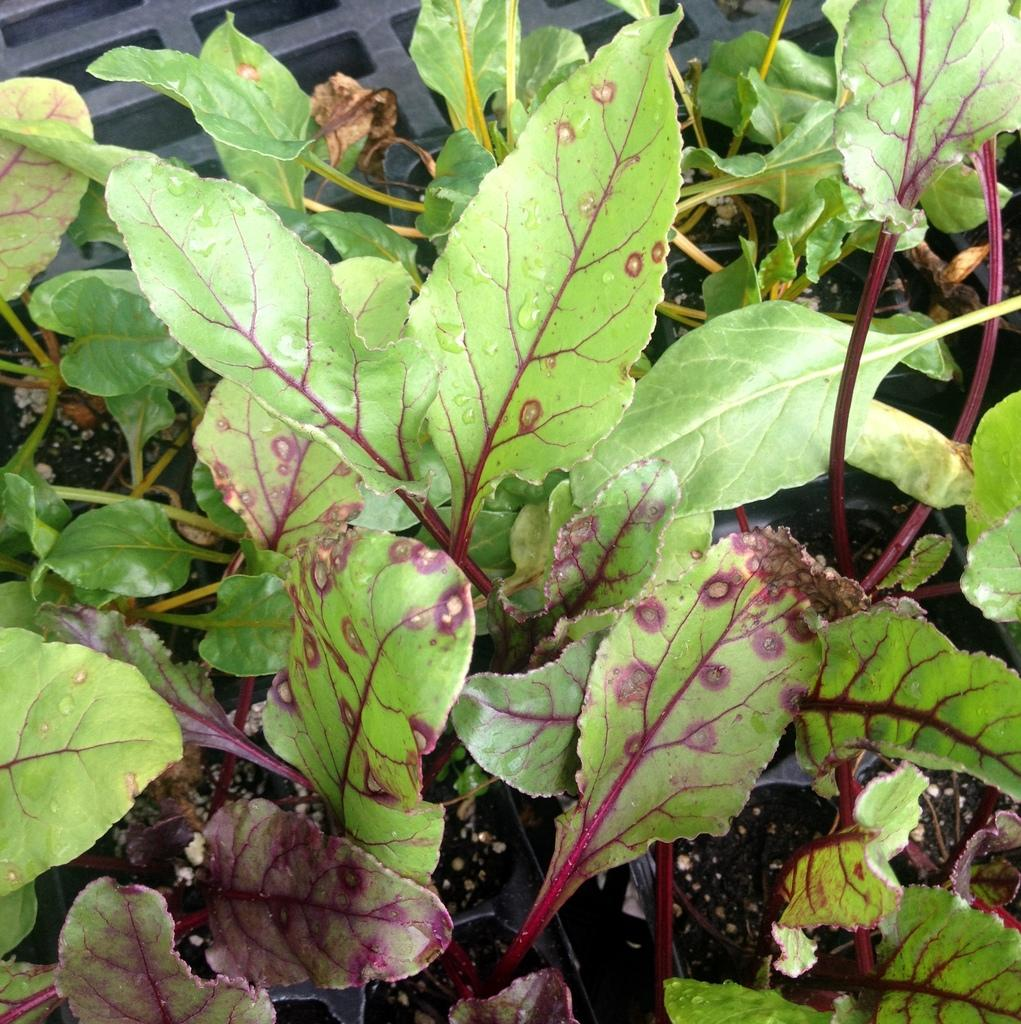What type of plants are in the image? There are spinach plants in the image. What type of nail is being used to fix the boat in the image? There is no boat or nail present in the image; it only features spinach plants. 